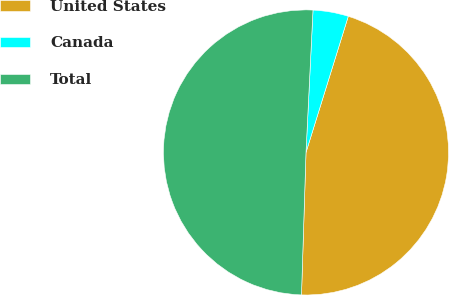Convert chart. <chart><loc_0><loc_0><loc_500><loc_500><pie_chart><fcel>United States<fcel>Canada<fcel>Total<nl><fcel>45.71%<fcel>4.01%<fcel>50.28%<nl></chart> 